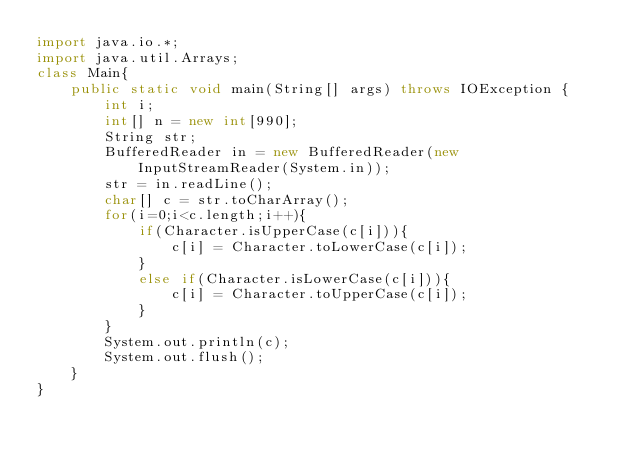<code> <loc_0><loc_0><loc_500><loc_500><_Java_>import java.io.*;
import java.util.Arrays;
class Main{
    public static void main(String[] args) throws IOException {
        int i;
        int[] n = new int[990];
        String str;
        BufferedReader in = new BufferedReader(new InputStreamReader(System.in));
        str = in.readLine();
        char[] c = str.toCharArray();
        for(i=0;i<c.length;i++){
            if(Character.isUpperCase(c[i])){
                c[i] = Character.toLowerCase(c[i]);
            }
            else if(Character.isLowerCase(c[i])){
                c[i] = Character.toUpperCase(c[i]);
            }
        }
        System.out.println(c);   
        System.out.flush();
    }
}</code> 